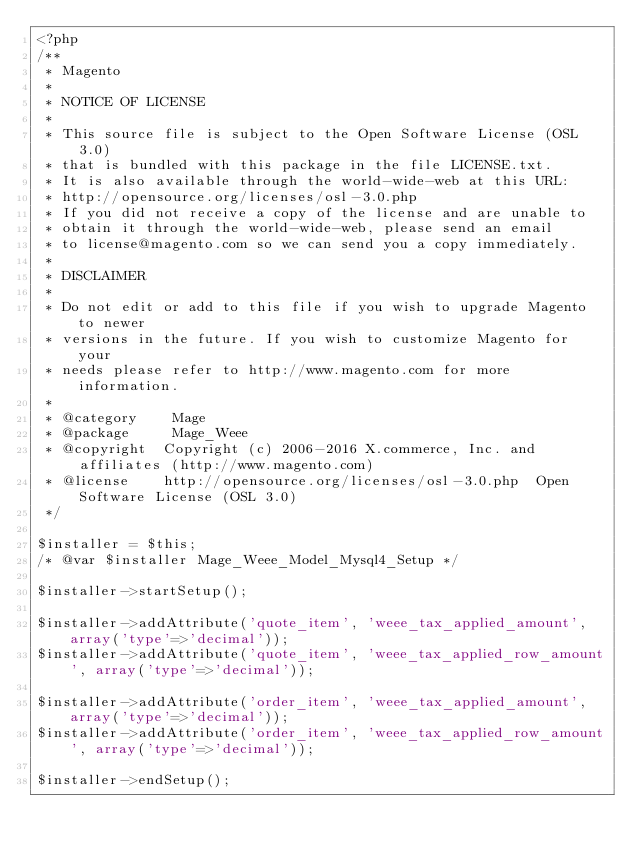<code> <loc_0><loc_0><loc_500><loc_500><_PHP_><?php
/**
 * Magento
 *
 * NOTICE OF LICENSE
 *
 * This source file is subject to the Open Software License (OSL 3.0)
 * that is bundled with this package in the file LICENSE.txt.
 * It is also available through the world-wide-web at this URL:
 * http://opensource.org/licenses/osl-3.0.php
 * If you did not receive a copy of the license and are unable to
 * obtain it through the world-wide-web, please send an email
 * to license@magento.com so we can send you a copy immediately.
 *
 * DISCLAIMER
 *
 * Do not edit or add to this file if you wish to upgrade Magento to newer
 * versions in the future. If you wish to customize Magento for your
 * needs please refer to http://www.magento.com for more information.
 *
 * @category    Mage
 * @package     Mage_Weee
 * @copyright  Copyright (c) 2006-2016 X.commerce, Inc. and affiliates (http://www.magento.com)
 * @license    http://opensource.org/licenses/osl-3.0.php  Open Software License (OSL 3.0)
 */

$installer = $this;
/* @var $installer Mage_Weee_Model_Mysql4_Setup */

$installer->startSetup();

$installer->addAttribute('quote_item', 'weee_tax_applied_amount', array('type'=>'decimal'));
$installer->addAttribute('quote_item', 'weee_tax_applied_row_amount', array('type'=>'decimal'));

$installer->addAttribute('order_item', 'weee_tax_applied_amount', array('type'=>'decimal'));
$installer->addAttribute('order_item', 'weee_tax_applied_row_amount', array('type'=>'decimal'));

$installer->endSetup();
</code> 